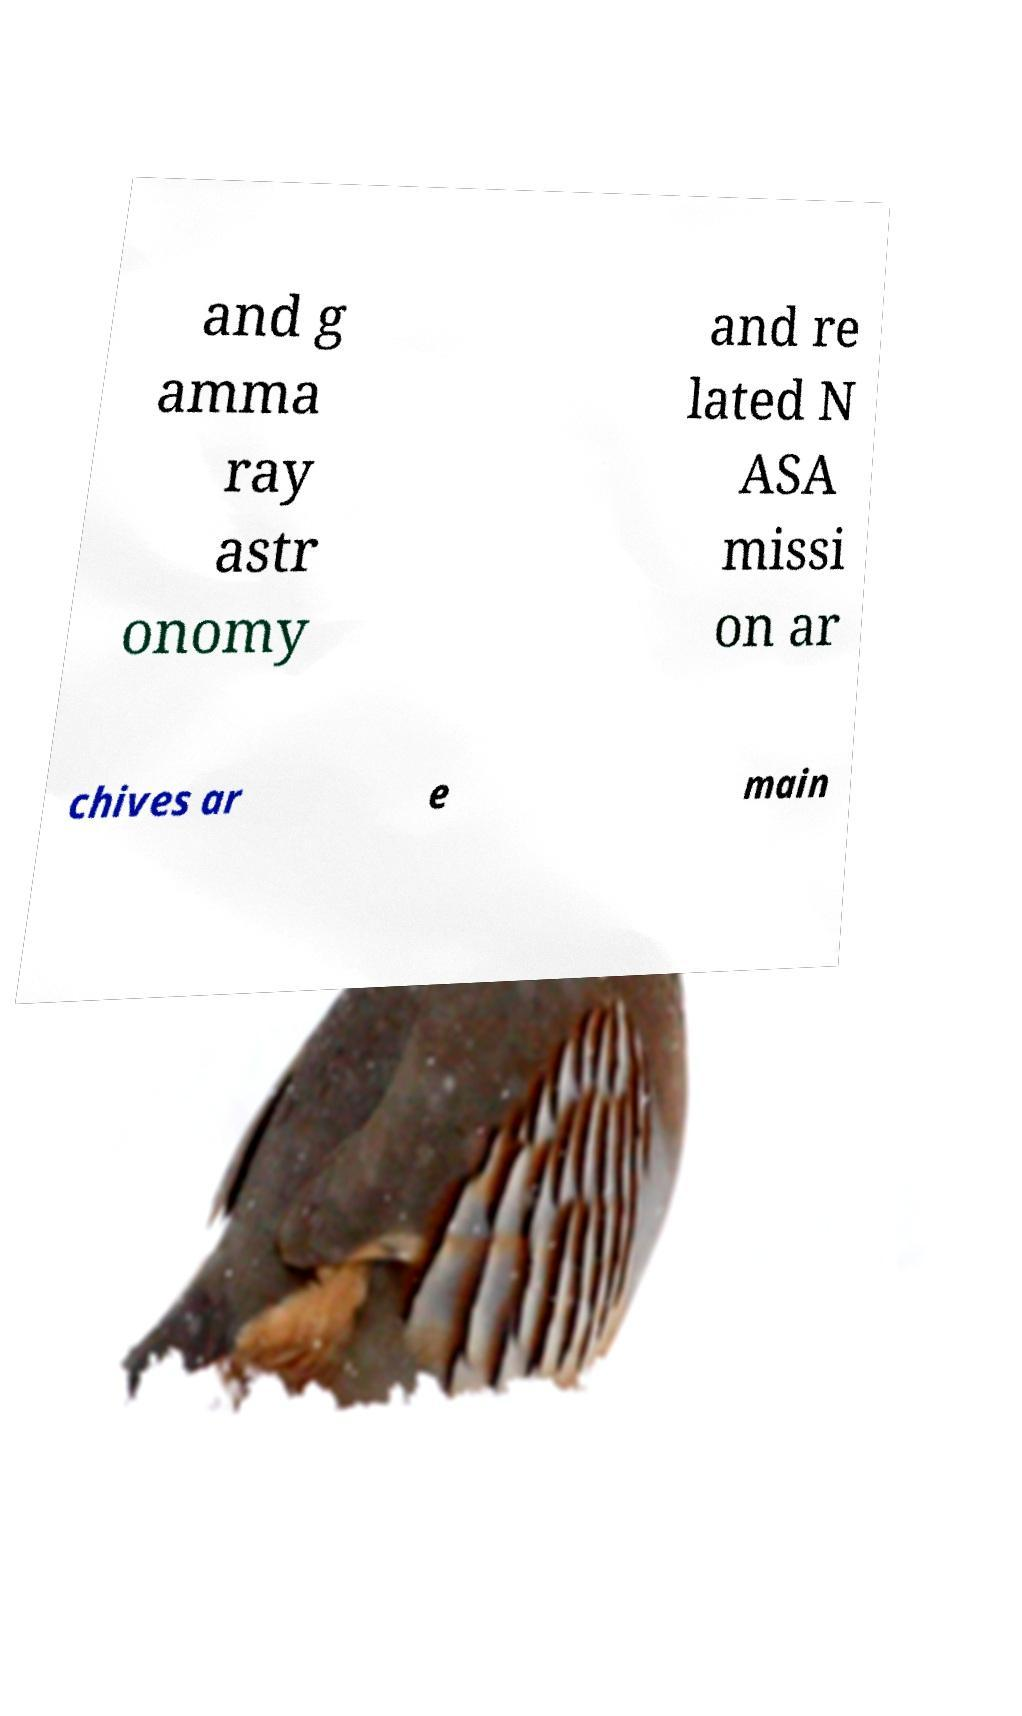Could you extract and type out the text from this image? and g amma ray astr onomy and re lated N ASA missi on ar chives ar e main 